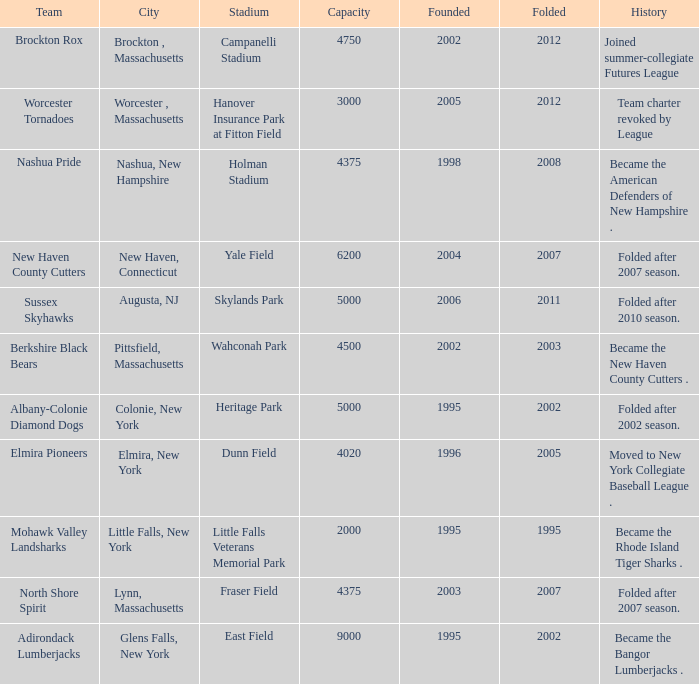What is the maximum folded value of the team whose stadium is Fraser Field? 2007.0. 